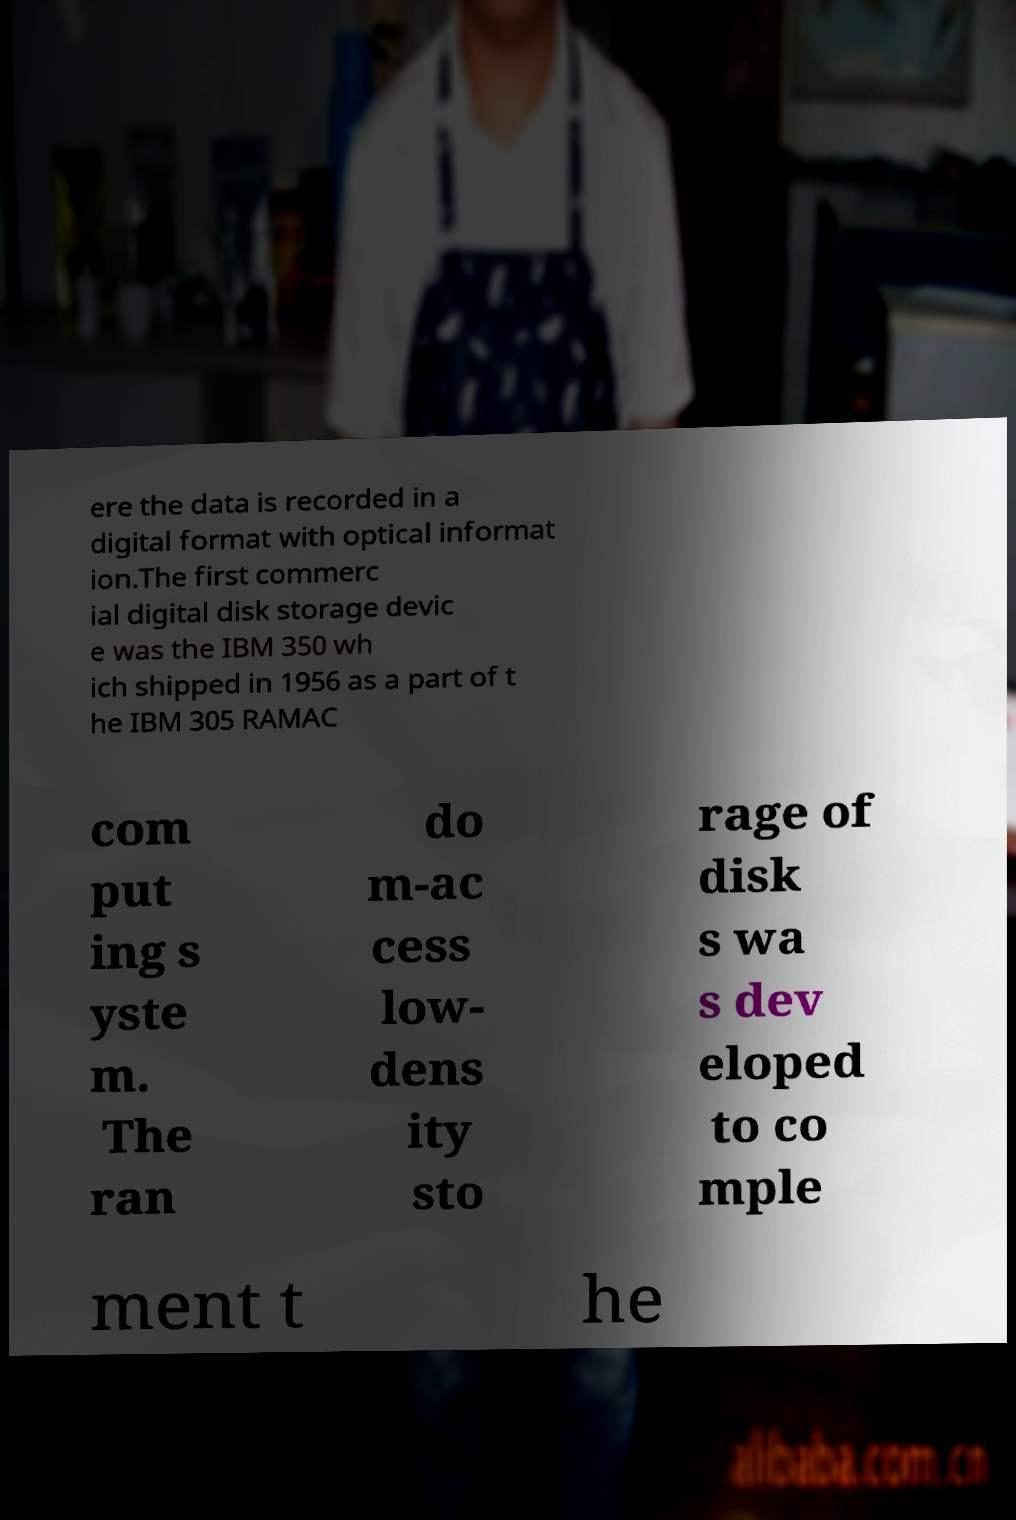What messages or text are displayed in this image? I need them in a readable, typed format. ere the data is recorded in a digital format with optical informat ion.The first commerc ial digital disk storage devic e was the IBM 350 wh ich shipped in 1956 as a part of t he IBM 305 RAMAC com put ing s yste m. The ran do m-ac cess low- dens ity sto rage of disk s wa s dev eloped to co mple ment t he 